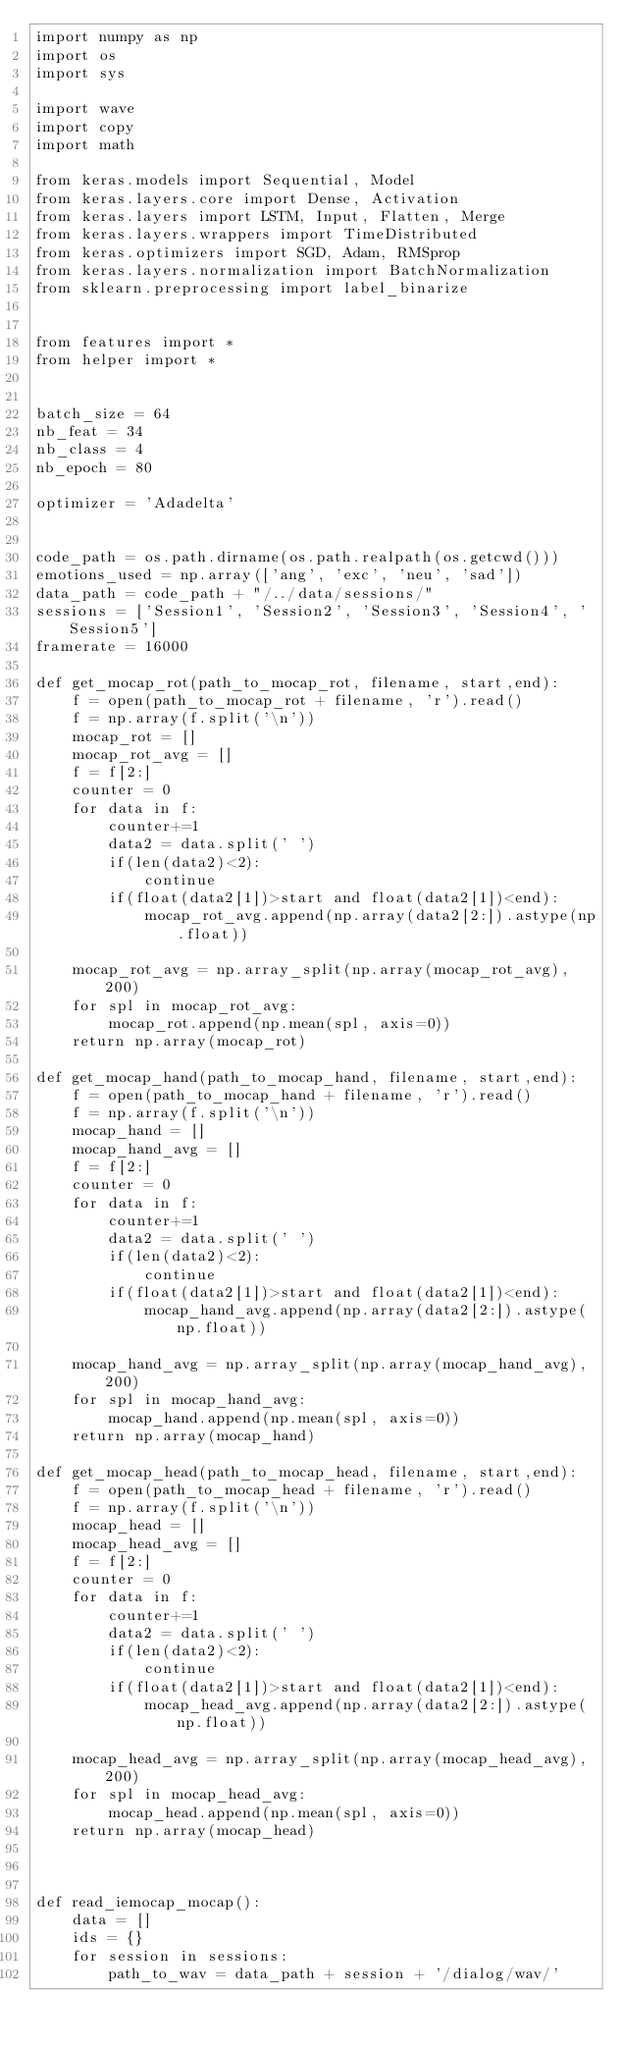<code> <loc_0><loc_0><loc_500><loc_500><_Python_>import numpy as np
import os
import sys

import wave
import copy
import math

from keras.models import Sequential, Model
from keras.layers.core import Dense, Activation
from keras.layers import LSTM, Input, Flatten, Merge
from keras.layers.wrappers import TimeDistributed
from keras.optimizers import SGD, Adam, RMSprop
from keras.layers.normalization import BatchNormalization
from sklearn.preprocessing import label_binarize


from features import *
from helper import *


batch_size = 64
nb_feat = 34
nb_class = 4
nb_epoch = 80

optimizer = 'Adadelta'


code_path = os.path.dirname(os.path.realpath(os.getcwd()))
emotions_used = np.array(['ang', 'exc', 'neu', 'sad'])
data_path = code_path + "/../data/sessions/"
sessions = ['Session1', 'Session2', 'Session3', 'Session4', 'Session5']
framerate = 16000

def get_mocap_rot(path_to_mocap_rot, filename, start,end):
    f = open(path_to_mocap_rot + filename, 'r').read()
    f = np.array(f.split('\n'))
    mocap_rot = []
    mocap_rot_avg = []
    f = f[2:]
    counter = 0
    for data in f:
        counter+=1
        data2 = data.split(' ')
        if(len(data2)<2):
            continue
        if(float(data2[1])>start and float(data2[1])<end):
            mocap_rot_avg.append(np.array(data2[2:]).astype(np.float))
            
    mocap_rot_avg = np.array_split(np.array(mocap_rot_avg), 200)
    for spl in mocap_rot_avg:
        mocap_rot.append(np.mean(spl, axis=0))
    return np.array(mocap_rot)

def get_mocap_hand(path_to_mocap_hand, filename, start,end):
    f = open(path_to_mocap_hand + filename, 'r').read()
    f = np.array(f.split('\n'))
    mocap_hand = []
    mocap_hand_avg = []
    f = f[2:]
    counter = 0
    for data in f:
        counter+=1
        data2 = data.split(' ')
        if(len(data2)<2):
            continue
        if(float(data2[1])>start and float(data2[1])<end):
            mocap_hand_avg.append(np.array(data2[2:]).astype(np.float))
            
    mocap_hand_avg = np.array_split(np.array(mocap_hand_avg), 200)
    for spl in mocap_hand_avg:
        mocap_hand.append(np.mean(spl, axis=0))
    return np.array(mocap_hand)

def get_mocap_head(path_to_mocap_head, filename, start,end):
    f = open(path_to_mocap_head + filename, 'r').read()
    f = np.array(f.split('\n'))
    mocap_head = []
    mocap_head_avg = []
    f = f[2:]
    counter = 0
    for data in f:
        counter+=1
        data2 = data.split(' ')
        if(len(data2)<2):
            continue
        if(float(data2[1])>start and float(data2[1])<end):
            mocap_head_avg.append(np.array(data2[2:]).astype(np.float))
            
    mocap_head_avg = np.array_split(np.array(mocap_head_avg), 200)
    for spl in mocap_head_avg:
        mocap_head.append(np.mean(spl, axis=0))
    return np.array(mocap_head)



def read_iemocap_mocap():
    data = []
    ids = {}
    for session in sessions:
        path_to_wav = data_path + session + '/dialog/wav/'</code> 